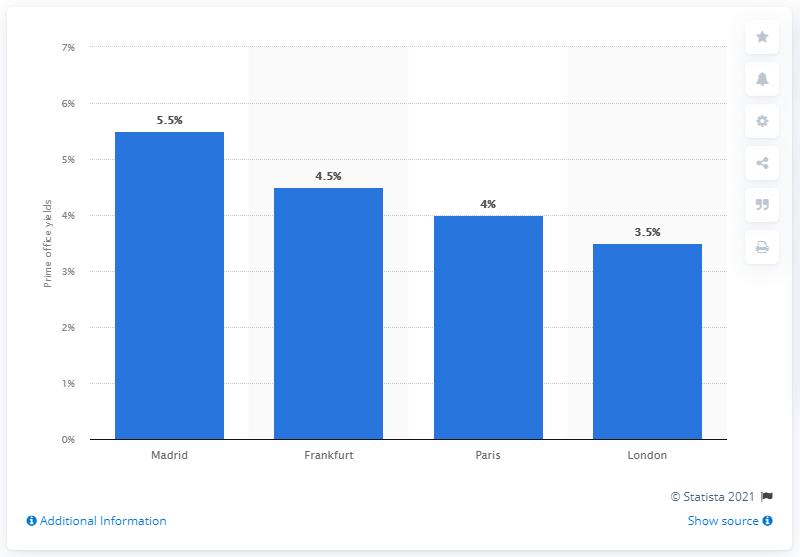Identify some key points in this picture. Madrid offered the highest returns for offices among European cities. The yield of commercial properties in Madrid's central business district in 2014 was 5.5%. 